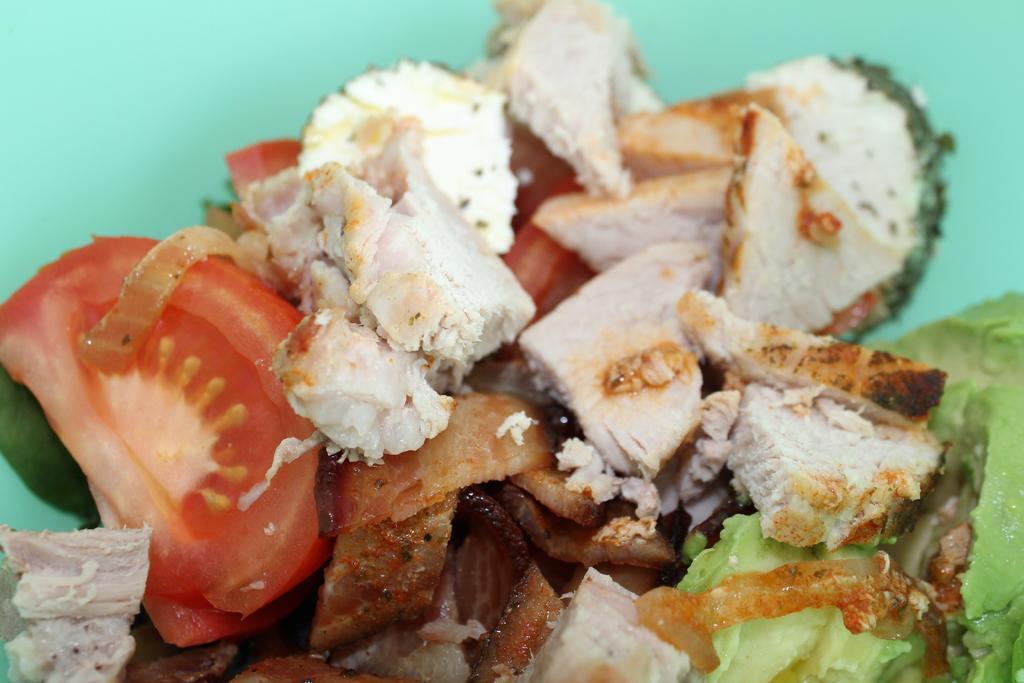In one or two sentences, can you explain what this image depicts? In this picture we can observe some vegetable pieces. We can observe tomato and cabbage. The background is in green color. 